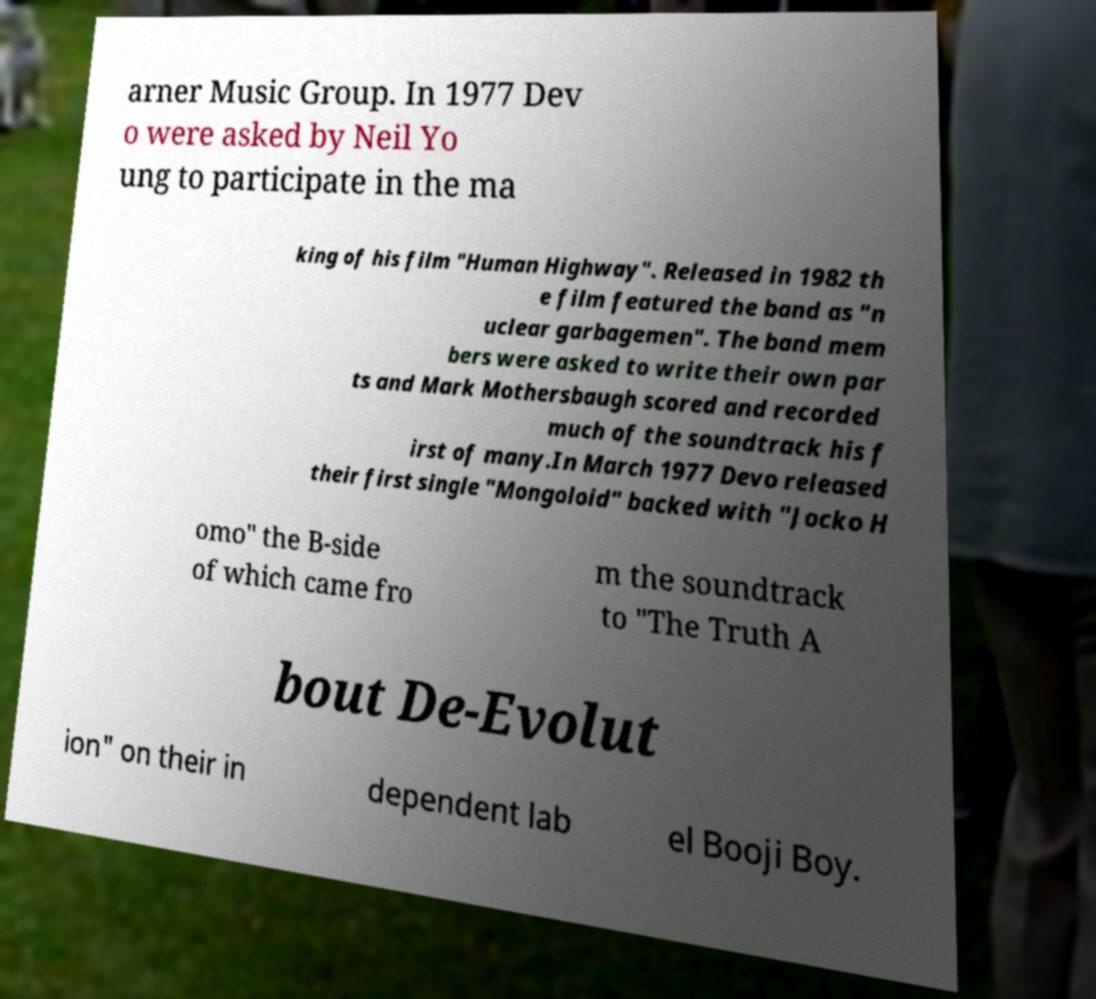Could you assist in decoding the text presented in this image and type it out clearly? arner Music Group. In 1977 Dev o were asked by Neil Yo ung to participate in the ma king of his film "Human Highway". Released in 1982 th e film featured the band as "n uclear garbagemen". The band mem bers were asked to write their own par ts and Mark Mothersbaugh scored and recorded much of the soundtrack his f irst of many.In March 1977 Devo released their first single "Mongoloid" backed with "Jocko H omo" the B-side of which came fro m the soundtrack to "The Truth A bout De-Evolut ion" on their in dependent lab el Booji Boy. 